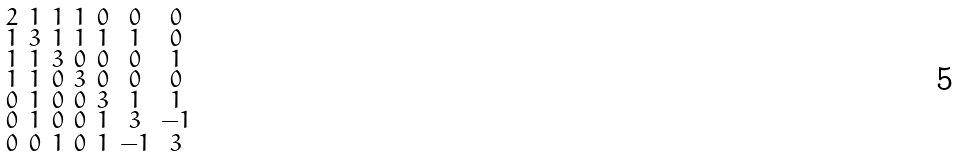Convert formula to latex. <formula><loc_0><loc_0><loc_500><loc_500>\begin{smallmatrix} 2 & 1 & 1 & 1 & 0 & 0 & 0 \\ 1 & 3 & 1 & 1 & 1 & 1 & 0 \\ 1 & 1 & 3 & 0 & 0 & 0 & 1 \\ 1 & 1 & 0 & 3 & 0 & 0 & 0 \\ 0 & 1 & 0 & 0 & 3 & 1 & 1 \\ 0 & 1 & 0 & 0 & 1 & 3 & - 1 \\ 0 & 0 & 1 & 0 & 1 & - 1 & 3 \end{smallmatrix}</formula> 